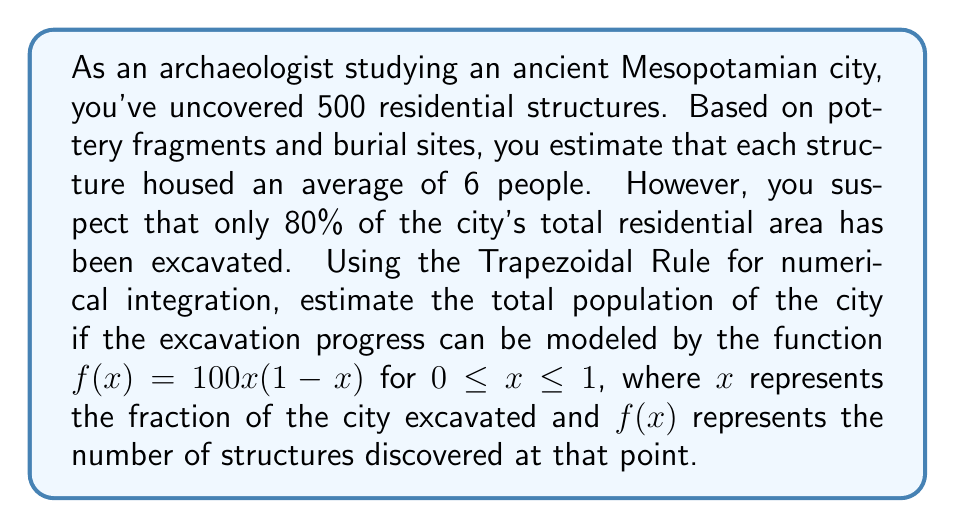Provide a solution to this math problem. 1. First, we need to calculate the number of people in the excavated area:
   $500 \text{ structures} \times 6 \text{ people/structure} = 3000 \text{ people}$

2. We know this represents 80% of the city, so we need to find the total population:
   $\text{Total population} = \frac{3000}{0.8} = 3750 \text{ people}$

3. Now, we need to verify this using the Trapezoidal Rule. The function $f(x) = 100x(1-x)$ represents the number of structures discovered at each point of excavation.

4. The Trapezoidal Rule for $n$ subintervals is given by:
   $$\int_{a}^{b} f(x) dx \approx \frac{b-a}{2n} [f(a) + 2f(x_1) + 2f(x_2) + ... + 2f(x_{n-1}) + f(b)]$$

5. We'll use $n=10$ subintervals for a good approximation. The interval is $[0,1]$, so $\Delta x = 0.1$

6. Calculate $f(x)$ for $x = 0, 0.1, 0.2, ..., 0.9, 1$:
   $f(0) = 0$
   $f(0.1) = 9$
   $f(0.2) = 16$
   $f(0.3) = 21$
   $f(0.4) = 24$
   $f(0.5) = 25$
   $f(0.6) = 24$
   $f(0.7) = 21$
   $f(0.8) = 16$
   $f(0.9) = 9$
   $f(1) = 0$

7. Apply the Trapezoidal Rule:
   $$\int_{0}^{1} f(x) dx \approx \frac{1-0}{2(10)} [0 + 2(9+16+21+24+25+24+21+16+9) + 0] = 16.5$$

8. This means the total number of structures in the city is approximately 165.

9. To get the total population, multiply by 6 people per structure:
   $165 \times 6 = 990 \text{ people}$

10. The discrepancy between this result (990) and our initial estimate (3750) suggests that the function $f(x)$ may not accurately model the excavation progress. The archaeological estimate based on the actual discoveries is likely more reliable in this case.
Answer: 3750 people (based on archaeological evidence); mathematical model suggests 990 people, indicating potential issues with the model. 